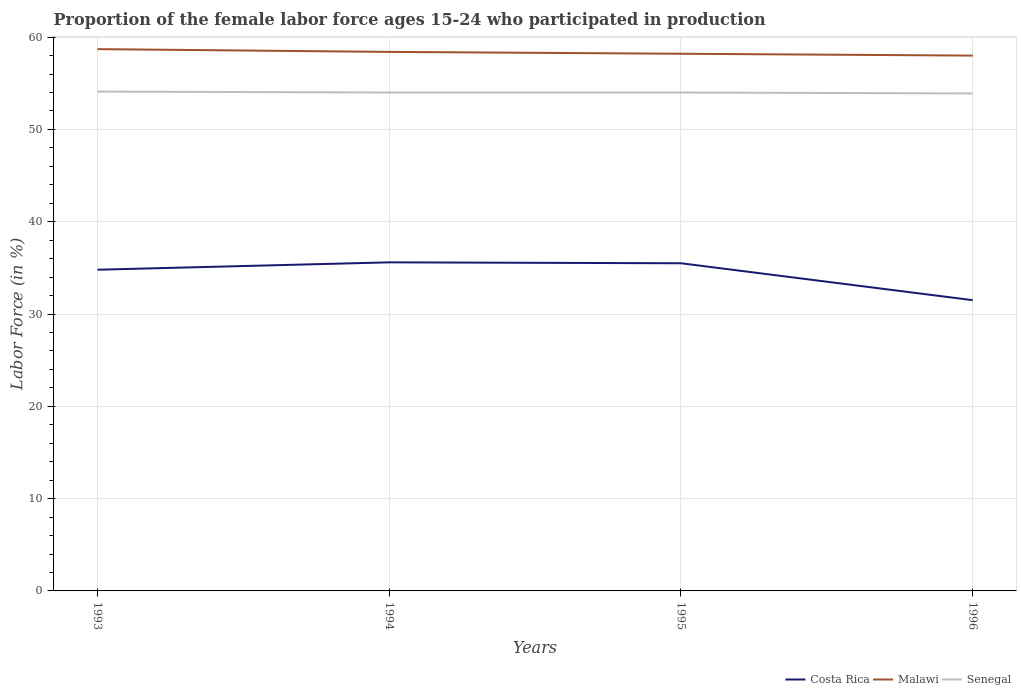Does the line corresponding to Costa Rica intersect with the line corresponding to Senegal?
Your answer should be compact. No. Across all years, what is the maximum proportion of the female labor force who participated in production in Senegal?
Your answer should be compact. 53.9. In which year was the proportion of the female labor force who participated in production in Senegal maximum?
Make the answer very short. 1996. What is the total proportion of the female labor force who participated in production in Malawi in the graph?
Your answer should be compact. 0.7. What is the difference between the highest and the second highest proportion of the female labor force who participated in production in Costa Rica?
Your response must be concise. 4.1. What is the difference between the highest and the lowest proportion of the female labor force who participated in production in Malawi?
Provide a succinct answer. 2. How many lines are there?
Offer a very short reply. 3. How many years are there in the graph?
Your response must be concise. 4. Where does the legend appear in the graph?
Your answer should be compact. Bottom right. How many legend labels are there?
Your answer should be very brief. 3. What is the title of the graph?
Your answer should be very brief. Proportion of the female labor force ages 15-24 who participated in production. Does "Gabon" appear as one of the legend labels in the graph?
Make the answer very short. No. What is the label or title of the X-axis?
Provide a succinct answer. Years. What is the label or title of the Y-axis?
Give a very brief answer. Labor Force (in %). What is the Labor Force (in %) in Costa Rica in 1993?
Ensure brevity in your answer.  34.8. What is the Labor Force (in %) of Malawi in 1993?
Keep it short and to the point. 58.7. What is the Labor Force (in %) of Senegal in 1993?
Offer a terse response. 54.1. What is the Labor Force (in %) in Costa Rica in 1994?
Offer a very short reply. 35.6. What is the Labor Force (in %) of Malawi in 1994?
Your response must be concise. 58.4. What is the Labor Force (in %) in Costa Rica in 1995?
Make the answer very short. 35.5. What is the Labor Force (in %) in Malawi in 1995?
Your response must be concise. 58.2. What is the Labor Force (in %) of Costa Rica in 1996?
Ensure brevity in your answer.  31.5. What is the Labor Force (in %) of Malawi in 1996?
Give a very brief answer. 58. What is the Labor Force (in %) in Senegal in 1996?
Keep it short and to the point. 53.9. Across all years, what is the maximum Labor Force (in %) of Costa Rica?
Provide a succinct answer. 35.6. Across all years, what is the maximum Labor Force (in %) of Malawi?
Provide a succinct answer. 58.7. Across all years, what is the maximum Labor Force (in %) of Senegal?
Provide a succinct answer. 54.1. Across all years, what is the minimum Labor Force (in %) in Costa Rica?
Offer a terse response. 31.5. Across all years, what is the minimum Labor Force (in %) in Malawi?
Ensure brevity in your answer.  58. Across all years, what is the minimum Labor Force (in %) of Senegal?
Ensure brevity in your answer.  53.9. What is the total Labor Force (in %) in Costa Rica in the graph?
Your answer should be compact. 137.4. What is the total Labor Force (in %) of Malawi in the graph?
Provide a succinct answer. 233.3. What is the total Labor Force (in %) of Senegal in the graph?
Provide a short and direct response. 216. What is the difference between the Labor Force (in %) in Senegal in 1993 and that in 1994?
Offer a very short reply. 0.1. What is the difference between the Labor Force (in %) in Malawi in 1993 and that in 1995?
Your response must be concise. 0.5. What is the difference between the Labor Force (in %) in Senegal in 1993 and that in 1995?
Make the answer very short. 0.1. What is the difference between the Labor Force (in %) of Malawi in 1993 and that in 1996?
Provide a succinct answer. 0.7. What is the difference between the Labor Force (in %) in Costa Rica in 1994 and that in 1996?
Provide a succinct answer. 4.1. What is the difference between the Labor Force (in %) in Senegal in 1994 and that in 1996?
Offer a terse response. 0.1. What is the difference between the Labor Force (in %) of Malawi in 1995 and that in 1996?
Provide a short and direct response. 0.2. What is the difference between the Labor Force (in %) in Costa Rica in 1993 and the Labor Force (in %) in Malawi in 1994?
Provide a succinct answer. -23.6. What is the difference between the Labor Force (in %) in Costa Rica in 1993 and the Labor Force (in %) in Senegal in 1994?
Offer a very short reply. -19.2. What is the difference between the Labor Force (in %) in Costa Rica in 1993 and the Labor Force (in %) in Malawi in 1995?
Keep it short and to the point. -23.4. What is the difference between the Labor Force (in %) of Costa Rica in 1993 and the Labor Force (in %) of Senegal in 1995?
Your answer should be very brief. -19.2. What is the difference between the Labor Force (in %) of Malawi in 1993 and the Labor Force (in %) of Senegal in 1995?
Ensure brevity in your answer.  4.7. What is the difference between the Labor Force (in %) of Costa Rica in 1993 and the Labor Force (in %) of Malawi in 1996?
Offer a terse response. -23.2. What is the difference between the Labor Force (in %) of Costa Rica in 1993 and the Labor Force (in %) of Senegal in 1996?
Offer a very short reply. -19.1. What is the difference between the Labor Force (in %) in Costa Rica in 1994 and the Labor Force (in %) in Malawi in 1995?
Make the answer very short. -22.6. What is the difference between the Labor Force (in %) in Costa Rica in 1994 and the Labor Force (in %) in Senegal in 1995?
Your response must be concise. -18.4. What is the difference between the Labor Force (in %) in Costa Rica in 1994 and the Labor Force (in %) in Malawi in 1996?
Provide a succinct answer. -22.4. What is the difference between the Labor Force (in %) in Costa Rica in 1994 and the Labor Force (in %) in Senegal in 1996?
Your answer should be compact. -18.3. What is the difference between the Labor Force (in %) in Costa Rica in 1995 and the Labor Force (in %) in Malawi in 1996?
Give a very brief answer. -22.5. What is the difference between the Labor Force (in %) in Costa Rica in 1995 and the Labor Force (in %) in Senegal in 1996?
Make the answer very short. -18.4. What is the difference between the Labor Force (in %) of Malawi in 1995 and the Labor Force (in %) of Senegal in 1996?
Give a very brief answer. 4.3. What is the average Labor Force (in %) in Costa Rica per year?
Provide a short and direct response. 34.35. What is the average Labor Force (in %) of Malawi per year?
Offer a very short reply. 58.33. In the year 1993, what is the difference between the Labor Force (in %) of Costa Rica and Labor Force (in %) of Malawi?
Provide a short and direct response. -23.9. In the year 1993, what is the difference between the Labor Force (in %) of Costa Rica and Labor Force (in %) of Senegal?
Ensure brevity in your answer.  -19.3. In the year 1994, what is the difference between the Labor Force (in %) in Costa Rica and Labor Force (in %) in Malawi?
Your answer should be compact. -22.8. In the year 1994, what is the difference between the Labor Force (in %) of Costa Rica and Labor Force (in %) of Senegal?
Ensure brevity in your answer.  -18.4. In the year 1994, what is the difference between the Labor Force (in %) of Malawi and Labor Force (in %) of Senegal?
Your answer should be very brief. 4.4. In the year 1995, what is the difference between the Labor Force (in %) of Costa Rica and Labor Force (in %) of Malawi?
Provide a short and direct response. -22.7. In the year 1995, what is the difference between the Labor Force (in %) in Costa Rica and Labor Force (in %) in Senegal?
Your answer should be very brief. -18.5. In the year 1995, what is the difference between the Labor Force (in %) of Malawi and Labor Force (in %) of Senegal?
Keep it short and to the point. 4.2. In the year 1996, what is the difference between the Labor Force (in %) in Costa Rica and Labor Force (in %) in Malawi?
Ensure brevity in your answer.  -26.5. In the year 1996, what is the difference between the Labor Force (in %) of Costa Rica and Labor Force (in %) of Senegal?
Your response must be concise. -22.4. In the year 1996, what is the difference between the Labor Force (in %) of Malawi and Labor Force (in %) of Senegal?
Make the answer very short. 4.1. What is the ratio of the Labor Force (in %) in Costa Rica in 1993 to that in 1994?
Your answer should be compact. 0.98. What is the ratio of the Labor Force (in %) in Malawi in 1993 to that in 1994?
Make the answer very short. 1.01. What is the ratio of the Labor Force (in %) in Senegal in 1993 to that in 1994?
Your response must be concise. 1. What is the ratio of the Labor Force (in %) of Costa Rica in 1993 to that in 1995?
Your response must be concise. 0.98. What is the ratio of the Labor Force (in %) of Malawi in 1993 to that in 1995?
Your answer should be compact. 1.01. What is the ratio of the Labor Force (in %) of Senegal in 1993 to that in 1995?
Provide a short and direct response. 1. What is the ratio of the Labor Force (in %) of Costa Rica in 1993 to that in 1996?
Provide a succinct answer. 1.1. What is the ratio of the Labor Force (in %) of Malawi in 1993 to that in 1996?
Provide a short and direct response. 1.01. What is the ratio of the Labor Force (in %) of Costa Rica in 1994 to that in 1995?
Your answer should be compact. 1. What is the ratio of the Labor Force (in %) in Malawi in 1994 to that in 1995?
Offer a terse response. 1. What is the ratio of the Labor Force (in %) of Senegal in 1994 to that in 1995?
Your response must be concise. 1. What is the ratio of the Labor Force (in %) in Costa Rica in 1994 to that in 1996?
Make the answer very short. 1.13. What is the ratio of the Labor Force (in %) in Malawi in 1994 to that in 1996?
Your answer should be compact. 1.01. What is the ratio of the Labor Force (in %) of Senegal in 1994 to that in 1996?
Offer a very short reply. 1. What is the ratio of the Labor Force (in %) of Costa Rica in 1995 to that in 1996?
Provide a succinct answer. 1.13. What is the ratio of the Labor Force (in %) of Senegal in 1995 to that in 1996?
Provide a succinct answer. 1. What is the difference between the highest and the second highest Labor Force (in %) of Malawi?
Give a very brief answer. 0.3. What is the difference between the highest and the second highest Labor Force (in %) of Senegal?
Offer a terse response. 0.1. What is the difference between the highest and the lowest Labor Force (in %) of Malawi?
Give a very brief answer. 0.7. 